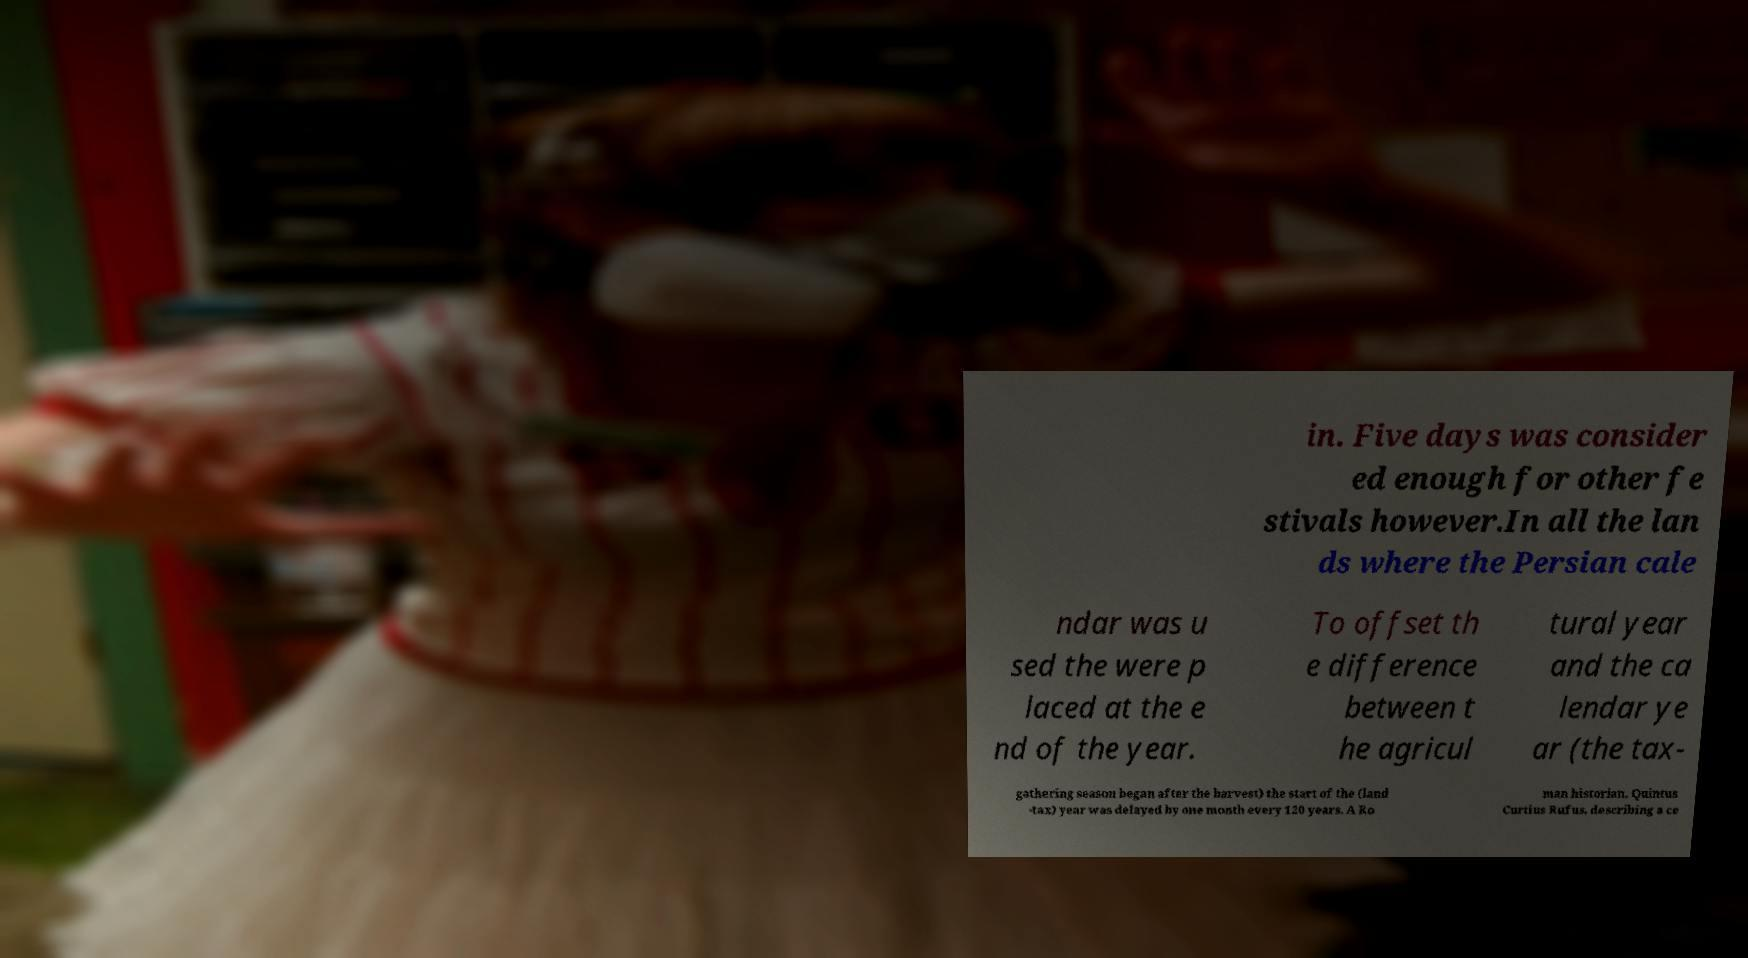Can you accurately transcribe the text from the provided image for me? in. Five days was consider ed enough for other fe stivals however.In all the lan ds where the Persian cale ndar was u sed the were p laced at the e nd of the year. To offset th e difference between t he agricul tural year and the ca lendar ye ar (the tax- gathering season began after the harvest) the start of the (land -tax) year was delayed by one month every 120 years. A Ro man historian, Quintus Curtius Rufus, describing a ce 